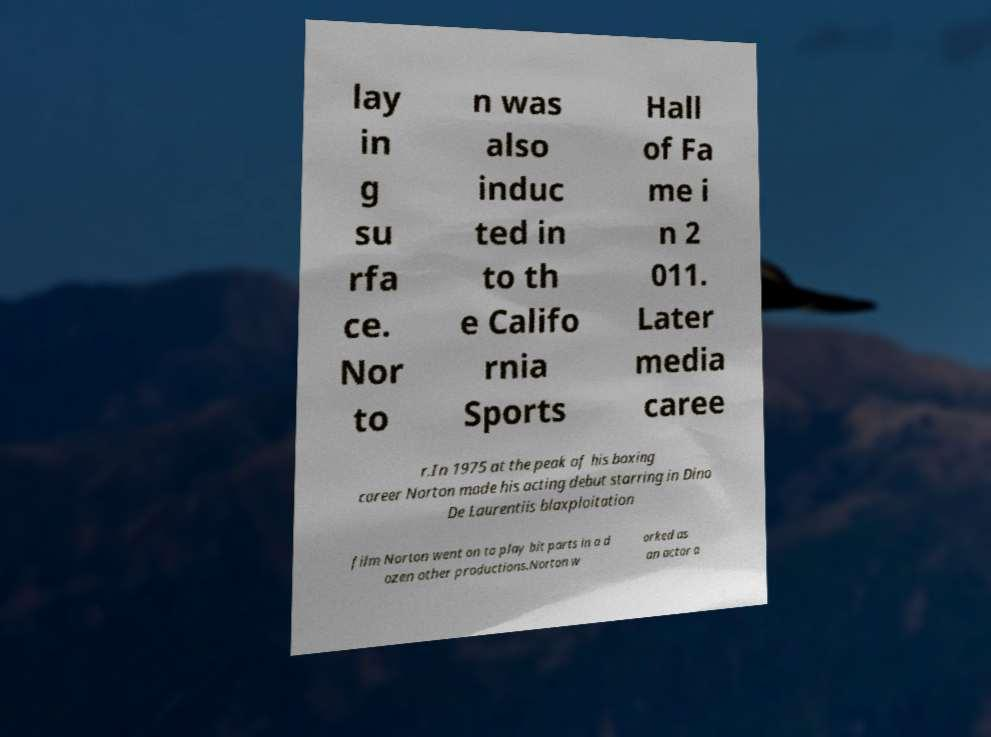Please read and relay the text visible in this image. What does it say? lay in g su rfa ce. Nor to n was also induc ted in to th e Califo rnia Sports Hall of Fa me i n 2 011. Later media caree r.In 1975 at the peak of his boxing career Norton made his acting debut starring in Dino De Laurentiis blaxploitation film Norton went on to play bit parts in a d ozen other productions.Norton w orked as an actor a 